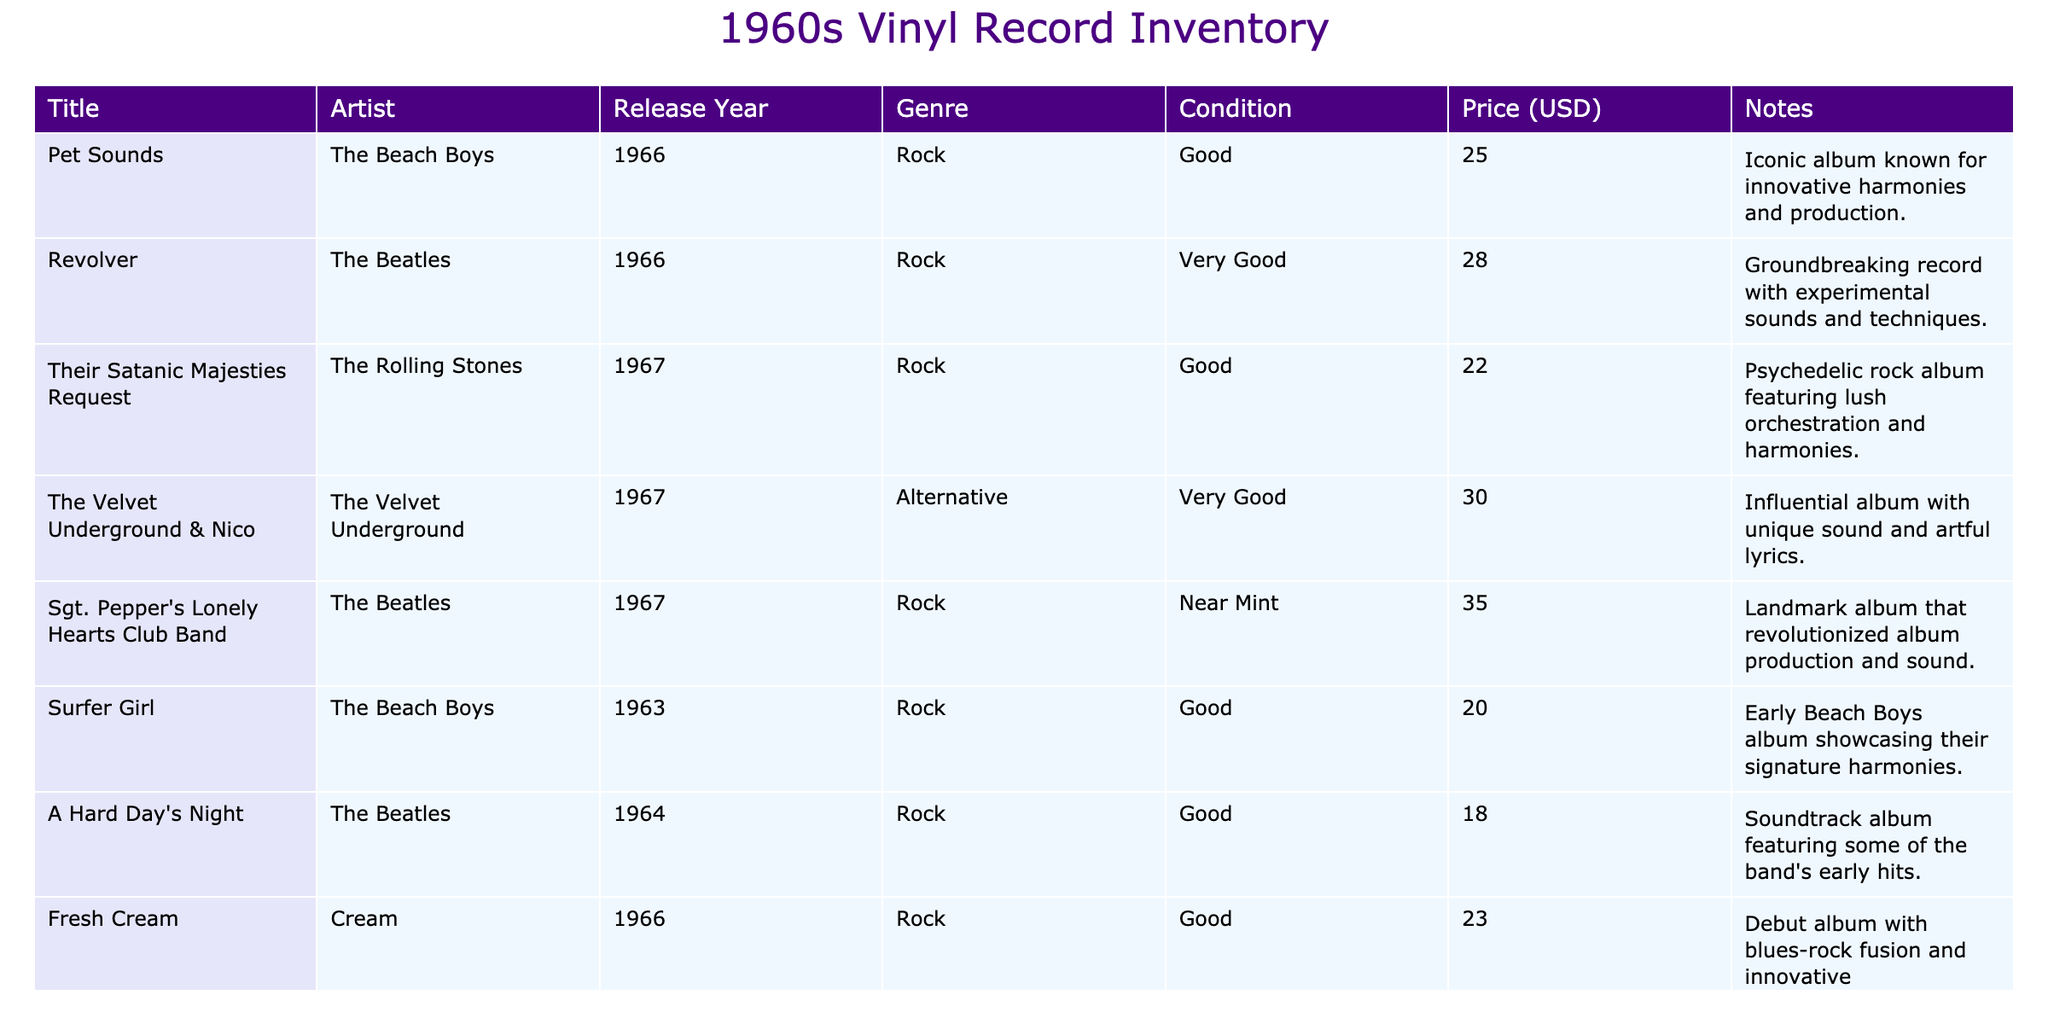What is the title of the album by The Beach Boys that was released in 1966? The table lists "Pet Sounds" as the title of the album released by The Beach Boys in 1966.
Answer: Pet Sounds Which artist released the album "Revolver"? The table shows that "Revolver" was released by The Beatles.
Answer: The Beatles How many albums are listed in the inventory? Counting the entries in the table shows there are 8 albums listed.
Answer: 8 What is the price of "Sgt. Pepper's Lonely Hearts Club Band"? According to the table, the price of "Sgt. Pepper's Lonely Hearts Club Band" is 35 USD.
Answer: 35 Is "Fresh Cream" in good condition? The table indicates that "Fresh Cream" is in good condition.
Answer: Yes What is the average price of the albums classified as 'Good'? The prices of the albums in 'Good' condition are 25, 22, 20, 18, and 23. Summing these gives 25 + 22 + 20 + 18 + 23 = 108. There are 5 albums, so the average is 108/5 = 21.6.
Answer: 21.6 Which genre has the highest-priced album, and what is that album's title? Looking at the prices, "Sgt. Pepper's Lonely Hearts Club Band" priced at 35 USD is the highest. It belongs to the 'Rock' genre.
Answer: Rock, Sgt. Pepper's Lonely Hearts Club Band What percentage of the albums are categorized as "Very Good"? There are 8 albums in total, and 3 of them are in "Very Good" condition (Revolver, The Velvet Underground & Nico, and Odessey and Oracle). To find the percentage, calculate (3/8) * 100, which equals 37.5%.
Answer: 37.5% 